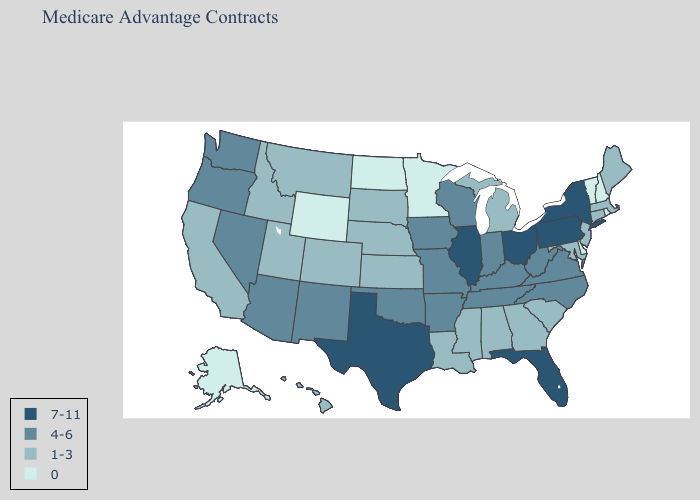What is the highest value in the South ?
Give a very brief answer. 7-11. Name the states that have a value in the range 7-11?
Quick response, please. Florida, Illinois, New York, Ohio, Pennsylvania, Texas. Name the states that have a value in the range 0?
Short answer required. Alaska, Delaware, Minnesota, North Dakota, New Hampshire, Rhode Island, Vermont, Wyoming. Does North Dakota have the lowest value in the USA?
Give a very brief answer. Yes. Which states have the highest value in the USA?
Answer briefly. Florida, Illinois, New York, Ohio, Pennsylvania, Texas. Does Michigan have the lowest value in the MidWest?
Be succinct. No. Name the states that have a value in the range 1-3?
Short answer required. Alabama, California, Colorado, Connecticut, Georgia, Hawaii, Idaho, Kansas, Louisiana, Massachusetts, Maryland, Maine, Michigan, Mississippi, Montana, Nebraska, New Jersey, South Carolina, South Dakota, Utah. Does New Jersey have the lowest value in the Northeast?
Keep it brief. No. Which states have the lowest value in the Northeast?
Concise answer only. New Hampshire, Rhode Island, Vermont. Among the states that border Idaho , does Wyoming have the lowest value?
Short answer required. Yes. Name the states that have a value in the range 1-3?
Give a very brief answer. Alabama, California, Colorado, Connecticut, Georgia, Hawaii, Idaho, Kansas, Louisiana, Massachusetts, Maryland, Maine, Michigan, Mississippi, Montana, Nebraska, New Jersey, South Carolina, South Dakota, Utah. What is the highest value in the USA?
Be succinct. 7-11. What is the highest value in the USA?
Be succinct. 7-11. Which states hav the highest value in the Northeast?
Keep it brief. New York, Pennsylvania. Which states have the highest value in the USA?
Keep it brief. Florida, Illinois, New York, Ohio, Pennsylvania, Texas. 